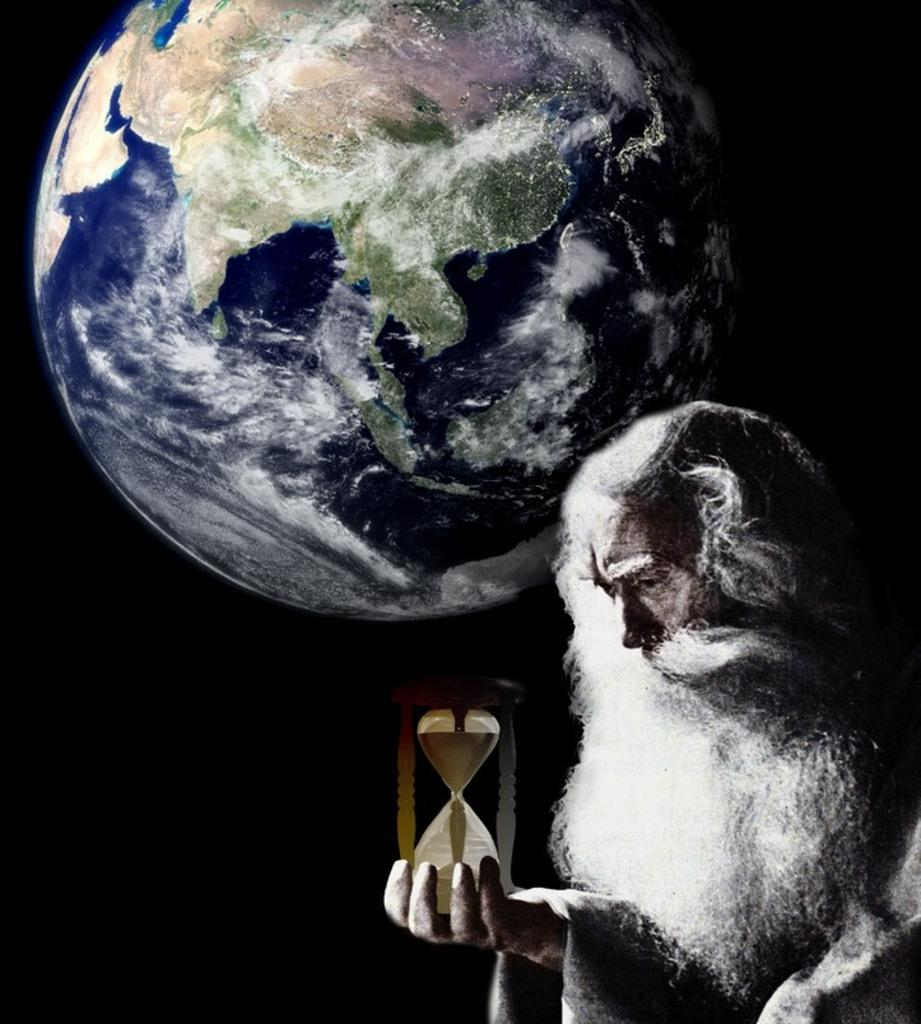Who or what is the main subject in the image? There is a person in the image. What is the person holding in his hand? The person is holding a sand clock in his hand. Can you describe the background of the image? The background of the image is dark. What can be seen in the background of the image besides the darkness? The earth is visible in the background of the image. What type of work is the person doing with their ear in the image? There is no indication in the image that the person is doing any work with their ear. 